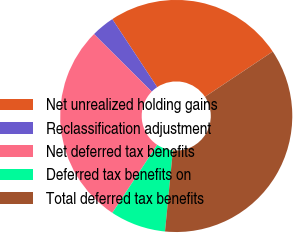Convert chart. <chart><loc_0><loc_0><loc_500><loc_500><pie_chart><fcel>Net unrealized holding gains<fcel>Reclassification adjustment<fcel>Net deferred tax benefits<fcel>Deferred tax benefits on<fcel>Total deferred tax benefits<nl><fcel>24.92%<fcel>3.25%<fcel>28.18%<fcel>7.74%<fcel>35.91%<nl></chart> 